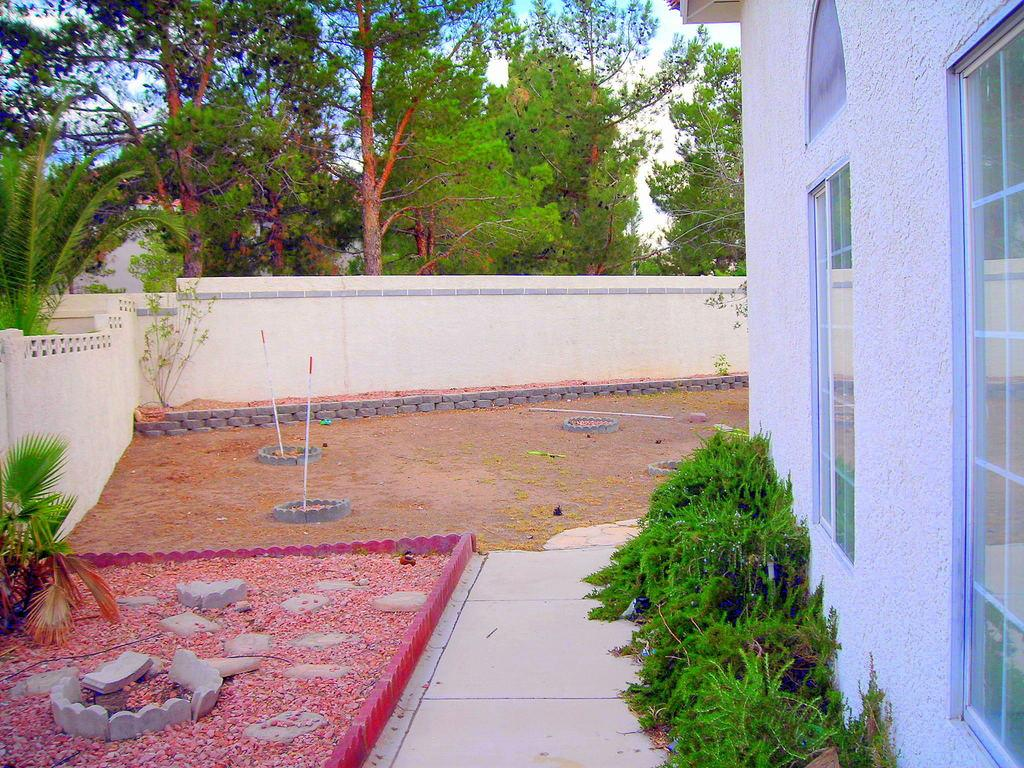What type of living organisms can be seen in the image? Plants and trees are visible in the image. What type of material is present in the image? Stones and walls are present in the image. What type of path can be seen in the image? There is a path in the image. What type of structure is visible in the image? There is a building with windows in the image. What else can be seen in the image? There are some objects in the image. What is visible in the background of the image? The sky is visible in the background of the image. Can you tell me how many airplanes are parked at the airport in the image? There is no airport present in the image, so it is not possible to determine the number of airplanes. What type of root system can be seen growing from the plants in the image? There is no root system visible in the image, as the focus is on the plants and trees as a whole, not their individual parts. 